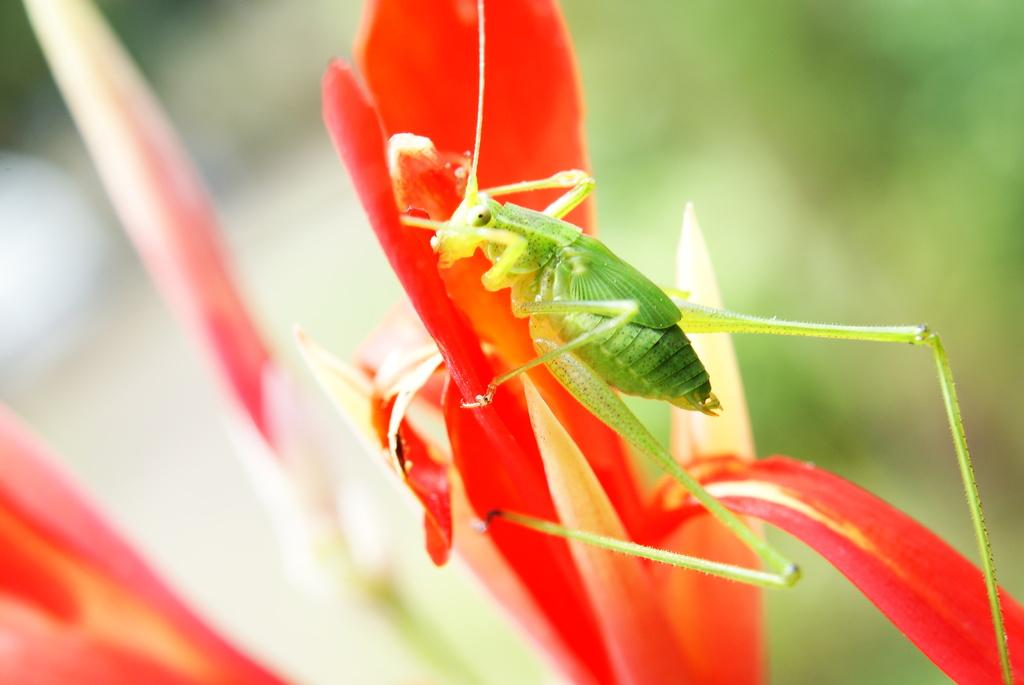What is the main subject of the image? The main subject of the image is a grasshopper. Where is the grasshopper located in the image? The grasshopper is on a flower. What language is the grasshopper speaking in the image? Grasshoppers do not speak any language, so this question cannot be answered. 